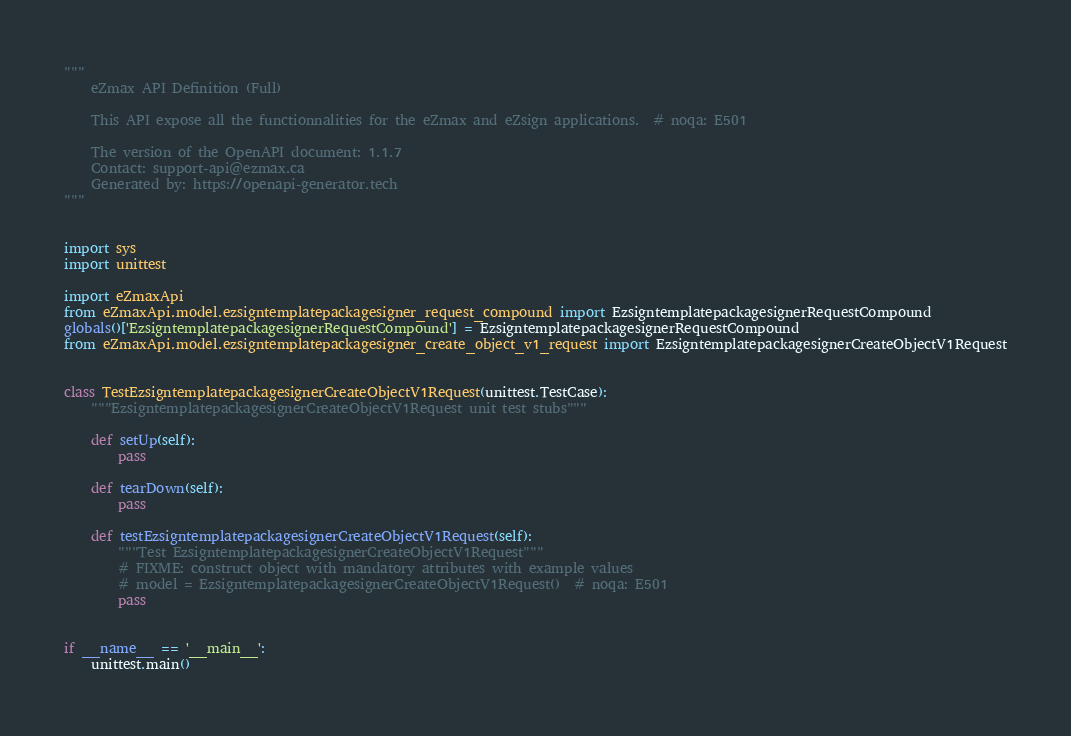Convert code to text. <code><loc_0><loc_0><loc_500><loc_500><_Python_>"""
    eZmax API Definition (Full)

    This API expose all the functionnalities for the eZmax and eZsign applications.  # noqa: E501

    The version of the OpenAPI document: 1.1.7
    Contact: support-api@ezmax.ca
    Generated by: https://openapi-generator.tech
"""


import sys
import unittest

import eZmaxApi
from eZmaxApi.model.ezsigntemplatepackagesigner_request_compound import EzsigntemplatepackagesignerRequestCompound
globals()['EzsigntemplatepackagesignerRequestCompound'] = EzsigntemplatepackagesignerRequestCompound
from eZmaxApi.model.ezsigntemplatepackagesigner_create_object_v1_request import EzsigntemplatepackagesignerCreateObjectV1Request


class TestEzsigntemplatepackagesignerCreateObjectV1Request(unittest.TestCase):
    """EzsigntemplatepackagesignerCreateObjectV1Request unit test stubs"""

    def setUp(self):
        pass

    def tearDown(self):
        pass

    def testEzsigntemplatepackagesignerCreateObjectV1Request(self):
        """Test EzsigntemplatepackagesignerCreateObjectV1Request"""
        # FIXME: construct object with mandatory attributes with example values
        # model = EzsigntemplatepackagesignerCreateObjectV1Request()  # noqa: E501
        pass


if __name__ == '__main__':
    unittest.main()
</code> 